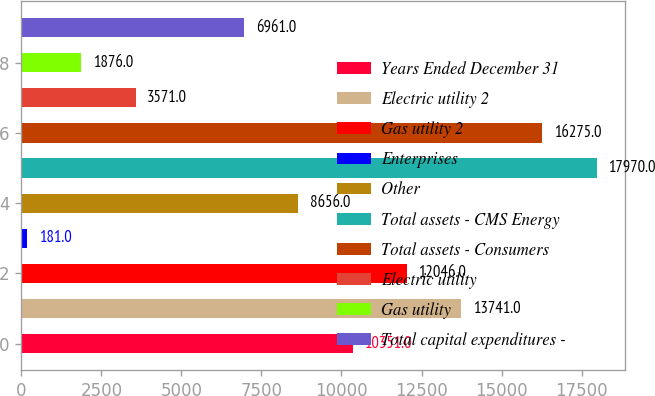<chart> <loc_0><loc_0><loc_500><loc_500><bar_chart><fcel>Years Ended December 31<fcel>Electric utility 2<fcel>Gas utility 2<fcel>Enterprises<fcel>Other<fcel>Total assets - CMS Energy<fcel>Total assets - Consumers<fcel>Electric utility<fcel>Gas utility<fcel>Total capital expenditures -<nl><fcel>10351<fcel>13741<fcel>12046<fcel>181<fcel>8656<fcel>17970<fcel>16275<fcel>3571<fcel>1876<fcel>6961<nl></chart> 